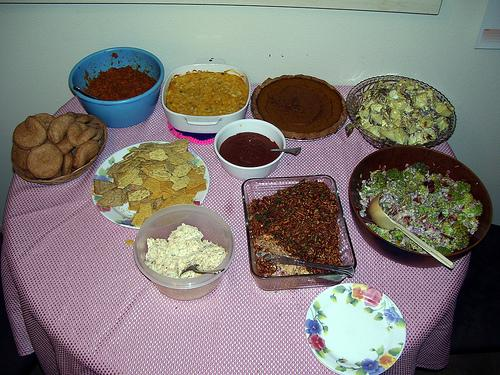Question: what color is the table?
Choices:
A. Brown.
B. Gray.
C. Red.
D. Pink.
Answer with the letter. Answer: D Question: where was the picture taken?
Choices:
A. On the moon.
B. In a classroom.
C. At a table.
D. Underwater.
Answer with the letter. Answer: C Question: what is in the picture?
Choices:
A. Food.
B. Cellphones.
C. Coffee beans.
D. Lego bricks.
Answer with the letter. Answer: A Question: why was the picture taken?
Choices:
A. To demonstrate plumbing technique.
B. To document brain surgery.
C. To show the food.
D. To prove the existence of aliens.
Answer with the letter. Answer: C Question: when was the picture taken?
Choices:
A. After bedtime.
B. During baseball game.
C. In the middle of the night.
D. Before dinner.
Answer with the letter. Answer: D 